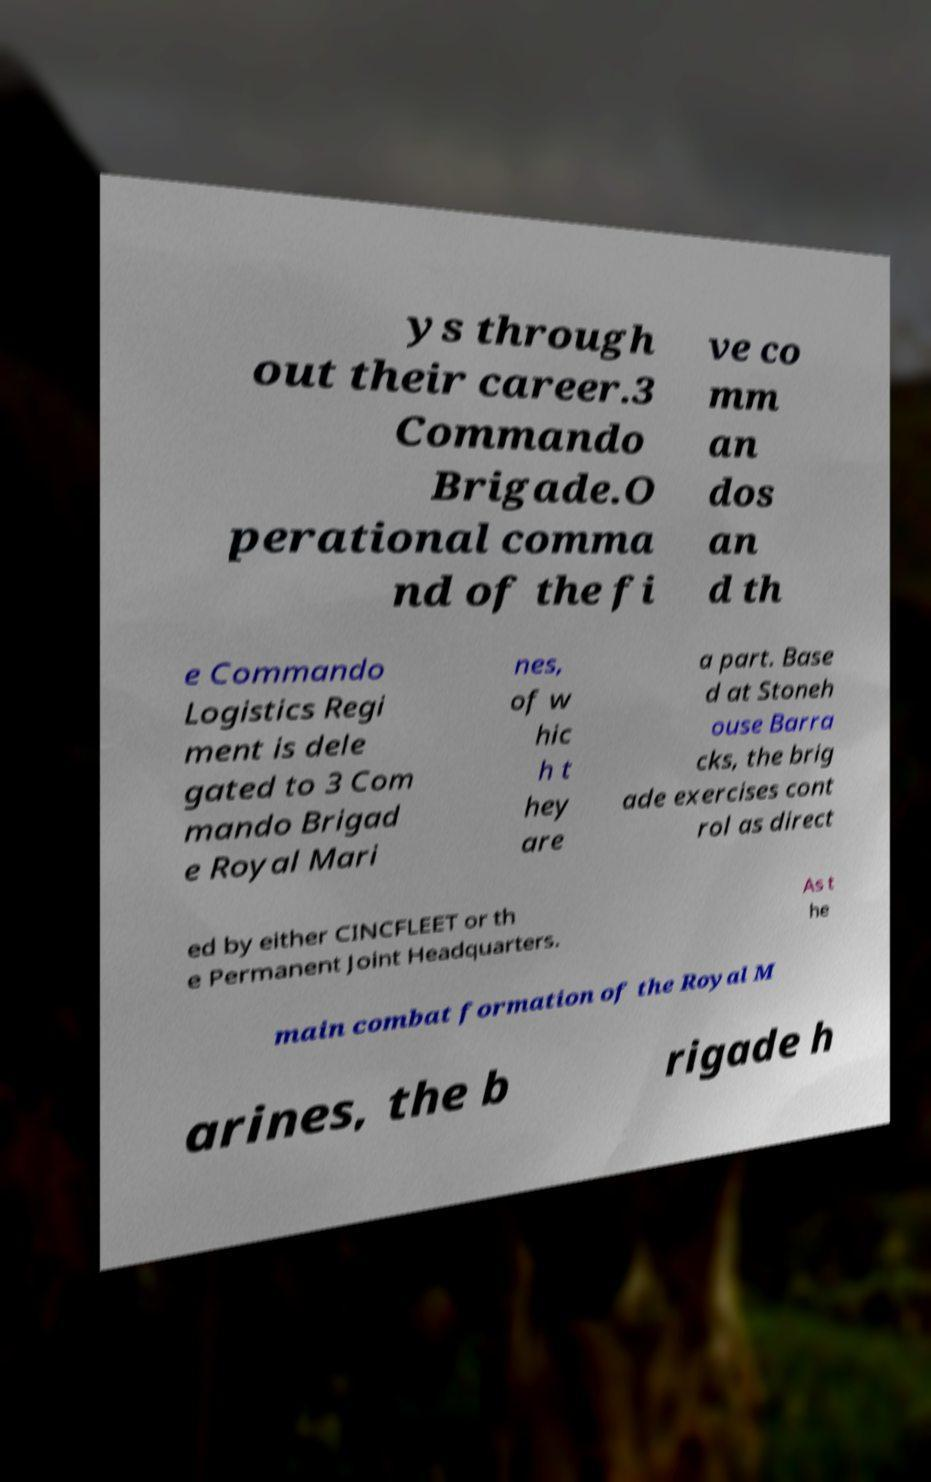Can you accurately transcribe the text from the provided image for me? ys through out their career.3 Commando Brigade.O perational comma nd of the fi ve co mm an dos an d th e Commando Logistics Regi ment is dele gated to 3 Com mando Brigad e Royal Mari nes, of w hic h t hey are a part. Base d at Stoneh ouse Barra cks, the brig ade exercises cont rol as direct ed by either CINCFLEET or th e Permanent Joint Headquarters. As t he main combat formation of the Royal M arines, the b rigade h 